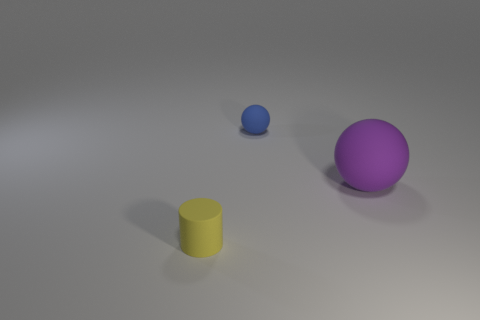Subtract all red cylinders. Subtract all brown blocks. How many cylinders are left? 1 Add 3 small matte objects. How many objects exist? 6 Subtract all cylinders. How many objects are left? 2 Add 3 small green things. How many small green things exist? 3 Subtract 0 red cylinders. How many objects are left? 3 Subtract all small yellow shiny objects. Subtract all blue matte things. How many objects are left? 2 Add 1 purple matte spheres. How many purple matte spheres are left? 2 